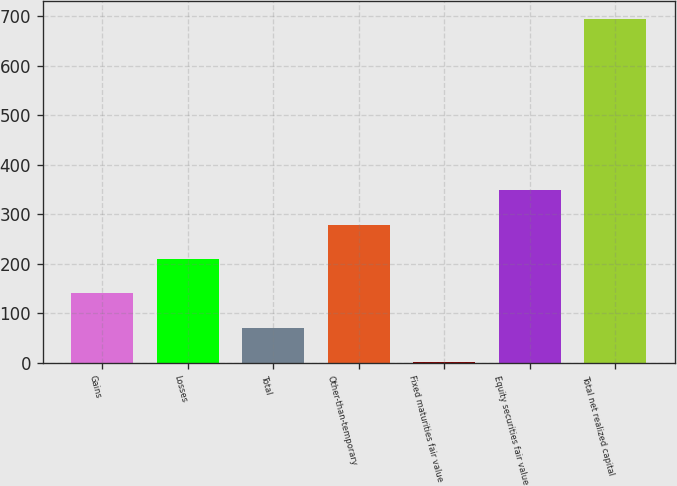Convert chart to OTSL. <chart><loc_0><loc_0><loc_500><loc_500><bar_chart><fcel>Gains<fcel>Losses<fcel>Total<fcel>Other-than-temporary<fcel>Fixed maturities fair value<fcel>Equity securities fair value<fcel>Total net realized capital<nl><fcel>140.36<fcel>209.79<fcel>70.93<fcel>279.22<fcel>1.5<fcel>348.65<fcel>695.8<nl></chart> 